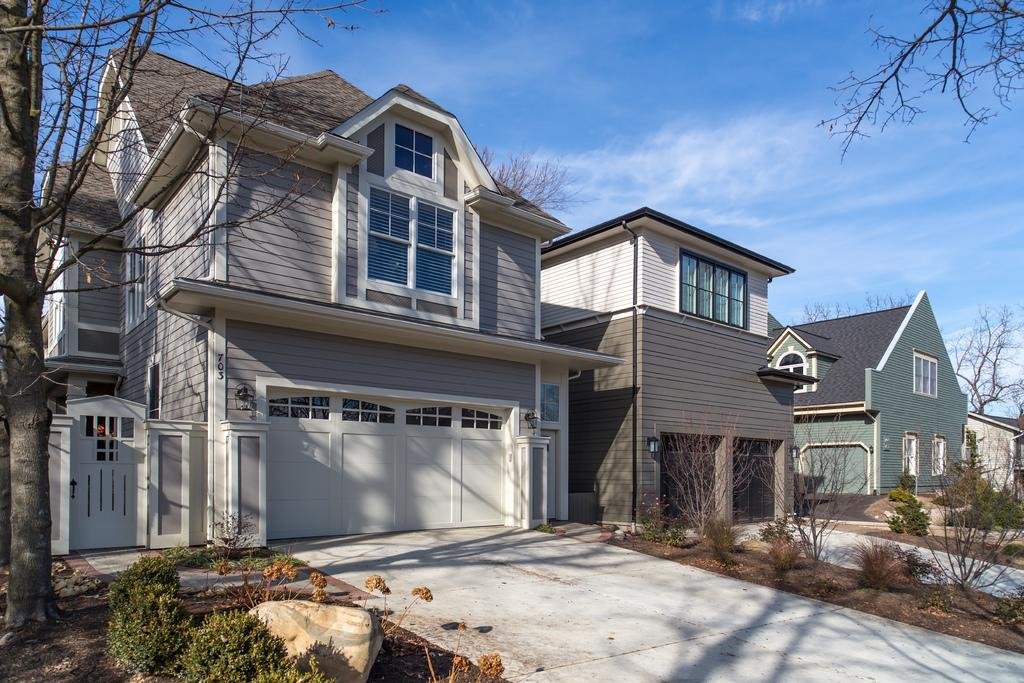What type of structures can be seen in the image? There are buildings in the image. What is located in the front of the image? There are plants in the front of the image. Where is the tree situated in the image? The tree is on the left side of the image. What is visible at the top of the image? The sky is visible at the top of the image. Can you tell me how the tree is smiling in the image? Trees do not have the ability to smile, so there is no tree smiling in the image. What type of lead is being used by the tree to interact with the buildings? There is no lead or interaction between the tree and the buildings in the image; they are separate elements in the scene. 